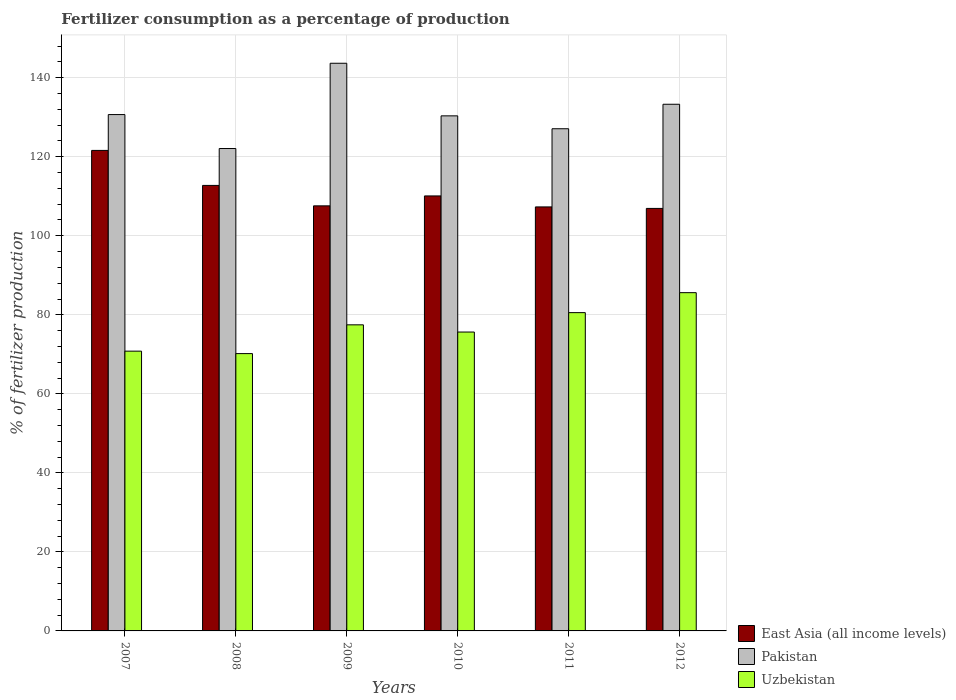How many groups of bars are there?
Keep it short and to the point. 6. How many bars are there on the 2nd tick from the right?
Offer a terse response. 3. What is the label of the 1st group of bars from the left?
Ensure brevity in your answer.  2007. In how many cases, is the number of bars for a given year not equal to the number of legend labels?
Ensure brevity in your answer.  0. What is the percentage of fertilizers consumed in Pakistan in 2011?
Give a very brief answer. 127.09. Across all years, what is the maximum percentage of fertilizers consumed in East Asia (all income levels)?
Your answer should be very brief. 121.6. Across all years, what is the minimum percentage of fertilizers consumed in East Asia (all income levels)?
Ensure brevity in your answer.  106.93. In which year was the percentage of fertilizers consumed in East Asia (all income levels) maximum?
Keep it short and to the point. 2007. In which year was the percentage of fertilizers consumed in Uzbekistan minimum?
Your response must be concise. 2008. What is the total percentage of fertilizers consumed in East Asia (all income levels) in the graph?
Give a very brief answer. 666.24. What is the difference between the percentage of fertilizers consumed in Uzbekistan in 2008 and that in 2011?
Your answer should be compact. -10.37. What is the difference between the percentage of fertilizers consumed in Uzbekistan in 2011 and the percentage of fertilizers consumed in East Asia (all income levels) in 2010?
Ensure brevity in your answer.  -29.53. What is the average percentage of fertilizers consumed in Uzbekistan per year?
Keep it short and to the point. 76.71. In the year 2007, what is the difference between the percentage of fertilizers consumed in Pakistan and percentage of fertilizers consumed in Uzbekistan?
Your answer should be very brief. 59.87. In how many years, is the percentage of fertilizers consumed in Pakistan greater than 44 %?
Offer a terse response. 6. What is the ratio of the percentage of fertilizers consumed in East Asia (all income levels) in 2008 to that in 2012?
Your answer should be very brief. 1.05. What is the difference between the highest and the second highest percentage of fertilizers consumed in East Asia (all income levels)?
Offer a very short reply. 8.86. What is the difference between the highest and the lowest percentage of fertilizers consumed in Pakistan?
Offer a terse response. 21.58. In how many years, is the percentage of fertilizers consumed in Pakistan greater than the average percentage of fertilizers consumed in Pakistan taken over all years?
Make the answer very short. 2. What does the 1st bar from the left in 2012 represents?
Keep it short and to the point. East Asia (all income levels). What does the 1st bar from the right in 2009 represents?
Provide a short and direct response. Uzbekistan. How many bars are there?
Provide a short and direct response. 18. Are all the bars in the graph horizontal?
Ensure brevity in your answer.  No. Are the values on the major ticks of Y-axis written in scientific E-notation?
Your response must be concise. No. Does the graph contain any zero values?
Your answer should be very brief. No. Where does the legend appear in the graph?
Give a very brief answer. Bottom right. How many legend labels are there?
Provide a short and direct response. 3. How are the legend labels stacked?
Give a very brief answer. Vertical. What is the title of the graph?
Offer a terse response. Fertilizer consumption as a percentage of production. What is the label or title of the Y-axis?
Your response must be concise. % of fertilizer production. What is the % of fertilizer production in East Asia (all income levels) in 2007?
Keep it short and to the point. 121.6. What is the % of fertilizer production in Pakistan in 2007?
Offer a very short reply. 130.68. What is the % of fertilizer production of Uzbekistan in 2007?
Your answer should be compact. 70.8. What is the % of fertilizer production in East Asia (all income levels) in 2008?
Keep it short and to the point. 112.75. What is the % of fertilizer production in Pakistan in 2008?
Give a very brief answer. 122.08. What is the % of fertilizer production of Uzbekistan in 2008?
Ensure brevity in your answer.  70.18. What is the % of fertilizer production in East Asia (all income levels) in 2009?
Offer a very short reply. 107.58. What is the % of fertilizer production in Pakistan in 2009?
Keep it short and to the point. 143.66. What is the % of fertilizer production in Uzbekistan in 2009?
Make the answer very short. 77.46. What is the % of fertilizer production in East Asia (all income levels) in 2010?
Your answer should be very brief. 110.09. What is the % of fertilizer production in Pakistan in 2010?
Offer a terse response. 130.35. What is the % of fertilizer production of Uzbekistan in 2010?
Offer a very short reply. 75.64. What is the % of fertilizer production of East Asia (all income levels) in 2011?
Offer a very short reply. 107.3. What is the % of fertilizer production in Pakistan in 2011?
Make the answer very short. 127.09. What is the % of fertilizer production of Uzbekistan in 2011?
Give a very brief answer. 80.55. What is the % of fertilizer production of East Asia (all income levels) in 2012?
Your answer should be very brief. 106.93. What is the % of fertilizer production in Pakistan in 2012?
Your answer should be very brief. 133.28. What is the % of fertilizer production in Uzbekistan in 2012?
Ensure brevity in your answer.  85.6. Across all years, what is the maximum % of fertilizer production of East Asia (all income levels)?
Your response must be concise. 121.6. Across all years, what is the maximum % of fertilizer production in Pakistan?
Keep it short and to the point. 143.66. Across all years, what is the maximum % of fertilizer production of Uzbekistan?
Your answer should be compact. 85.6. Across all years, what is the minimum % of fertilizer production of East Asia (all income levels)?
Keep it short and to the point. 106.93. Across all years, what is the minimum % of fertilizer production of Pakistan?
Your response must be concise. 122.08. Across all years, what is the minimum % of fertilizer production in Uzbekistan?
Your answer should be very brief. 70.18. What is the total % of fertilizer production in East Asia (all income levels) in the graph?
Your response must be concise. 666.24. What is the total % of fertilizer production in Pakistan in the graph?
Your response must be concise. 787.14. What is the total % of fertilizer production in Uzbekistan in the graph?
Ensure brevity in your answer.  460.25. What is the difference between the % of fertilizer production in East Asia (all income levels) in 2007 and that in 2008?
Make the answer very short. 8.86. What is the difference between the % of fertilizer production of Pakistan in 2007 and that in 2008?
Your response must be concise. 8.59. What is the difference between the % of fertilizer production of Uzbekistan in 2007 and that in 2008?
Your answer should be very brief. 0.62. What is the difference between the % of fertilizer production in East Asia (all income levels) in 2007 and that in 2009?
Your answer should be compact. 14.03. What is the difference between the % of fertilizer production in Pakistan in 2007 and that in 2009?
Your answer should be compact. -12.99. What is the difference between the % of fertilizer production of Uzbekistan in 2007 and that in 2009?
Ensure brevity in your answer.  -6.66. What is the difference between the % of fertilizer production in East Asia (all income levels) in 2007 and that in 2010?
Keep it short and to the point. 11.52. What is the difference between the % of fertilizer production of Pakistan in 2007 and that in 2010?
Offer a terse response. 0.32. What is the difference between the % of fertilizer production in Uzbekistan in 2007 and that in 2010?
Keep it short and to the point. -4.84. What is the difference between the % of fertilizer production of East Asia (all income levels) in 2007 and that in 2011?
Keep it short and to the point. 14.3. What is the difference between the % of fertilizer production of Pakistan in 2007 and that in 2011?
Your response must be concise. 3.59. What is the difference between the % of fertilizer production of Uzbekistan in 2007 and that in 2011?
Your response must be concise. -9.75. What is the difference between the % of fertilizer production in East Asia (all income levels) in 2007 and that in 2012?
Provide a short and direct response. 14.68. What is the difference between the % of fertilizer production of Pakistan in 2007 and that in 2012?
Your response must be concise. -2.61. What is the difference between the % of fertilizer production in Uzbekistan in 2007 and that in 2012?
Your answer should be very brief. -14.8. What is the difference between the % of fertilizer production of East Asia (all income levels) in 2008 and that in 2009?
Your answer should be compact. 5.17. What is the difference between the % of fertilizer production in Pakistan in 2008 and that in 2009?
Provide a short and direct response. -21.58. What is the difference between the % of fertilizer production of Uzbekistan in 2008 and that in 2009?
Your answer should be compact. -7.28. What is the difference between the % of fertilizer production in East Asia (all income levels) in 2008 and that in 2010?
Your answer should be compact. 2.66. What is the difference between the % of fertilizer production of Pakistan in 2008 and that in 2010?
Your answer should be very brief. -8.27. What is the difference between the % of fertilizer production in Uzbekistan in 2008 and that in 2010?
Your response must be concise. -5.46. What is the difference between the % of fertilizer production in East Asia (all income levels) in 2008 and that in 2011?
Keep it short and to the point. 5.44. What is the difference between the % of fertilizer production of Pakistan in 2008 and that in 2011?
Make the answer very short. -5.01. What is the difference between the % of fertilizer production in Uzbekistan in 2008 and that in 2011?
Provide a succinct answer. -10.37. What is the difference between the % of fertilizer production of East Asia (all income levels) in 2008 and that in 2012?
Ensure brevity in your answer.  5.82. What is the difference between the % of fertilizer production in Pakistan in 2008 and that in 2012?
Your response must be concise. -11.2. What is the difference between the % of fertilizer production in Uzbekistan in 2008 and that in 2012?
Ensure brevity in your answer.  -15.42. What is the difference between the % of fertilizer production of East Asia (all income levels) in 2009 and that in 2010?
Keep it short and to the point. -2.51. What is the difference between the % of fertilizer production in Pakistan in 2009 and that in 2010?
Your response must be concise. 13.31. What is the difference between the % of fertilizer production of Uzbekistan in 2009 and that in 2010?
Offer a terse response. 1.82. What is the difference between the % of fertilizer production of East Asia (all income levels) in 2009 and that in 2011?
Your answer should be compact. 0.27. What is the difference between the % of fertilizer production in Pakistan in 2009 and that in 2011?
Your answer should be very brief. 16.57. What is the difference between the % of fertilizer production of Uzbekistan in 2009 and that in 2011?
Ensure brevity in your answer.  -3.09. What is the difference between the % of fertilizer production of East Asia (all income levels) in 2009 and that in 2012?
Your response must be concise. 0.65. What is the difference between the % of fertilizer production of Pakistan in 2009 and that in 2012?
Provide a short and direct response. 10.38. What is the difference between the % of fertilizer production of Uzbekistan in 2009 and that in 2012?
Make the answer very short. -8.14. What is the difference between the % of fertilizer production in East Asia (all income levels) in 2010 and that in 2011?
Your response must be concise. 2.78. What is the difference between the % of fertilizer production in Pakistan in 2010 and that in 2011?
Your answer should be compact. 3.26. What is the difference between the % of fertilizer production of Uzbekistan in 2010 and that in 2011?
Your answer should be very brief. -4.91. What is the difference between the % of fertilizer production of East Asia (all income levels) in 2010 and that in 2012?
Provide a succinct answer. 3.16. What is the difference between the % of fertilizer production of Pakistan in 2010 and that in 2012?
Your response must be concise. -2.93. What is the difference between the % of fertilizer production of Uzbekistan in 2010 and that in 2012?
Your answer should be compact. -9.96. What is the difference between the % of fertilizer production of East Asia (all income levels) in 2011 and that in 2012?
Offer a terse response. 0.38. What is the difference between the % of fertilizer production in Pakistan in 2011 and that in 2012?
Make the answer very short. -6.19. What is the difference between the % of fertilizer production of Uzbekistan in 2011 and that in 2012?
Give a very brief answer. -5.05. What is the difference between the % of fertilizer production in East Asia (all income levels) in 2007 and the % of fertilizer production in Pakistan in 2008?
Provide a short and direct response. -0.48. What is the difference between the % of fertilizer production in East Asia (all income levels) in 2007 and the % of fertilizer production in Uzbekistan in 2008?
Provide a succinct answer. 51.42. What is the difference between the % of fertilizer production of Pakistan in 2007 and the % of fertilizer production of Uzbekistan in 2008?
Make the answer very short. 60.49. What is the difference between the % of fertilizer production in East Asia (all income levels) in 2007 and the % of fertilizer production in Pakistan in 2009?
Your answer should be very brief. -22.06. What is the difference between the % of fertilizer production in East Asia (all income levels) in 2007 and the % of fertilizer production in Uzbekistan in 2009?
Offer a very short reply. 44.14. What is the difference between the % of fertilizer production in Pakistan in 2007 and the % of fertilizer production in Uzbekistan in 2009?
Your response must be concise. 53.21. What is the difference between the % of fertilizer production in East Asia (all income levels) in 2007 and the % of fertilizer production in Pakistan in 2010?
Provide a succinct answer. -8.75. What is the difference between the % of fertilizer production of East Asia (all income levels) in 2007 and the % of fertilizer production of Uzbekistan in 2010?
Offer a terse response. 45.96. What is the difference between the % of fertilizer production in Pakistan in 2007 and the % of fertilizer production in Uzbekistan in 2010?
Your answer should be very brief. 55.03. What is the difference between the % of fertilizer production in East Asia (all income levels) in 2007 and the % of fertilizer production in Pakistan in 2011?
Your answer should be compact. -5.49. What is the difference between the % of fertilizer production of East Asia (all income levels) in 2007 and the % of fertilizer production of Uzbekistan in 2011?
Offer a very short reply. 41.05. What is the difference between the % of fertilizer production in Pakistan in 2007 and the % of fertilizer production in Uzbekistan in 2011?
Offer a very short reply. 50.12. What is the difference between the % of fertilizer production of East Asia (all income levels) in 2007 and the % of fertilizer production of Pakistan in 2012?
Provide a succinct answer. -11.68. What is the difference between the % of fertilizer production of East Asia (all income levels) in 2007 and the % of fertilizer production of Uzbekistan in 2012?
Your answer should be compact. 36. What is the difference between the % of fertilizer production in Pakistan in 2007 and the % of fertilizer production in Uzbekistan in 2012?
Provide a succinct answer. 45.07. What is the difference between the % of fertilizer production in East Asia (all income levels) in 2008 and the % of fertilizer production in Pakistan in 2009?
Your response must be concise. -30.91. What is the difference between the % of fertilizer production in East Asia (all income levels) in 2008 and the % of fertilizer production in Uzbekistan in 2009?
Give a very brief answer. 35.28. What is the difference between the % of fertilizer production in Pakistan in 2008 and the % of fertilizer production in Uzbekistan in 2009?
Provide a short and direct response. 44.62. What is the difference between the % of fertilizer production of East Asia (all income levels) in 2008 and the % of fertilizer production of Pakistan in 2010?
Ensure brevity in your answer.  -17.6. What is the difference between the % of fertilizer production in East Asia (all income levels) in 2008 and the % of fertilizer production in Uzbekistan in 2010?
Provide a succinct answer. 37.11. What is the difference between the % of fertilizer production of Pakistan in 2008 and the % of fertilizer production of Uzbekistan in 2010?
Ensure brevity in your answer.  46.44. What is the difference between the % of fertilizer production of East Asia (all income levels) in 2008 and the % of fertilizer production of Pakistan in 2011?
Keep it short and to the point. -14.34. What is the difference between the % of fertilizer production in East Asia (all income levels) in 2008 and the % of fertilizer production in Uzbekistan in 2011?
Your answer should be very brief. 32.19. What is the difference between the % of fertilizer production in Pakistan in 2008 and the % of fertilizer production in Uzbekistan in 2011?
Provide a short and direct response. 41.53. What is the difference between the % of fertilizer production in East Asia (all income levels) in 2008 and the % of fertilizer production in Pakistan in 2012?
Offer a terse response. -20.54. What is the difference between the % of fertilizer production in East Asia (all income levels) in 2008 and the % of fertilizer production in Uzbekistan in 2012?
Your answer should be compact. 27.14. What is the difference between the % of fertilizer production of Pakistan in 2008 and the % of fertilizer production of Uzbekistan in 2012?
Make the answer very short. 36.48. What is the difference between the % of fertilizer production in East Asia (all income levels) in 2009 and the % of fertilizer production in Pakistan in 2010?
Offer a terse response. -22.78. What is the difference between the % of fertilizer production of East Asia (all income levels) in 2009 and the % of fertilizer production of Uzbekistan in 2010?
Provide a short and direct response. 31.94. What is the difference between the % of fertilizer production of Pakistan in 2009 and the % of fertilizer production of Uzbekistan in 2010?
Provide a short and direct response. 68.02. What is the difference between the % of fertilizer production of East Asia (all income levels) in 2009 and the % of fertilizer production of Pakistan in 2011?
Provide a short and direct response. -19.51. What is the difference between the % of fertilizer production in East Asia (all income levels) in 2009 and the % of fertilizer production in Uzbekistan in 2011?
Offer a very short reply. 27.02. What is the difference between the % of fertilizer production of Pakistan in 2009 and the % of fertilizer production of Uzbekistan in 2011?
Make the answer very short. 63.11. What is the difference between the % of fertilizer production of East Asia (all income levels) in 2009 and the % of fertilizer production of Pakistan in 2012?
Provide a short and direct response. -25.71. What is the difference between the % of fertilizer production of East Asia (all income levels) in 2009 and the % of fertilizer production of Uzbekistan in 2012?
Your answer should be very brief. 21.97. What is the difference between the % of fertilizer production of Pakistan in 2009 and the % of fertilizer production of Uzbekistan in 2012?
Your response must be concise. 58.06. What is the difference between the % of fertilizer production of East Asia (all income levels) in 2010 and the % of fertilizer production of Pakistan in 2011?
Ensure brevity in your answer.  -17. What is the difference between the % of fertilizer production of East Asia (all income levels) in 2010 and the % of fertilizer production of Uzbekistan in 2011?
Ensure brevity in your answer.  29.53. What is the difference between the % of fertilizer production of Pakistan in 2010 and the % of fertilizer production of Uzbekistan in 2011?
Provide a short and direct response. 49.8. What is the difference between the % of fertilizer production of East Asia (all income levels) in 2010 and the % of fertilizer production of Pakistan in 2012?
Give a very brief answer. -23.2. What is the difference between the % of fertilizer production of East Asia (all income levels) in 2010 and the % of fertilizer production of Uzbekistan in 2012?
Your answer should be compact. 24.48. What is the difference between the % of fertilizer production in Pakistan in 2010 and the % of fertilizer production in Uzbekistan in 2012?
Provide a short and direct response. 44.75. What is the difference between the % of fertilizer production in East Asia (all income levels) in 2011 and the % of fertilizer production in Pakistan in 2012?
Offer a very short reply. -25.98. What is the difference between the % of fertilizer production of East Asia (all income levels) in 2011 and the % of fertilizer production of Uzbekistan in 2012?
Make the answer very short. 21.7. What is the difference between the % of fertilizer production in Pakistan in 2011 and the % of fertilizer production in Uzbekistan in 2012?
Your answer should be compact. 41.49. What is the average % of fertilizer production of East Asia (all income levels) per year?
Offer a very short reply. 111.04. What is the average % of fertilizer production of Pakistan per year?
Offer a very short reply. 131.19. What is the average % of fertilizer production in Uzbekistan per year?
Make the answer very short. 76.71. In the year 2007, what is the difference between the % of fertilizer production of East Asia (all income levels) and % of fertilizer production of Pakistan?
Offer a terse response. -9.07. In the year 2007, what is the difference between the % of fertilizer production in East Asia (all income levels) and % of fertilizer production in Uzbekistan?
Offer a terse response. 50.8. In the year 2007, what is the difference between the % of fertilizer production in Pakistan and % of fertilizer production in Uzbekistan?
Keep it short and to the point. 59.87. In the year 2008, what is the difference between the % of fertilizer production of East Asia (all income levels) and % of fertilizer production of Pakistan?
Provide a short and direct response. -9.33. In the year 2008, what is the difference between the % of fertilizer production in East Asia (all income levels) and % of fertilizer production in Uzbekistan?
Provide a short and direct response. 42.56. In the year 2008, what is the difference between the % of fertilizer production of Pakistan and % of fertilizer production of Uzbekistan?
Offer a very short reply. 51.9. In the year 2009, what is the difference between the % of fertilizer production of East Asia (all income levels) and % of fertilizer production of Pakistan?
Make the answer very short. -36.08. In the year 2009, what is the difference between the % of fertilizer production of East Asia (all income levels) and % of fertilizer production of Uzbekistan?
Give a very brief answer. 30.11. In the year 2009, what is the difference between the % of fertilizer production in Pakistan and % of fertilizer production in Uzbekistan?
Keep it short and to the point. 66.2. In the year 2010, what is the difference between the % of fertilizer production of East Asia (all income levels) and % of fertilizer production of Pakistan?
Keep it short and to the point. -20.27. In the year 2010, what is the difference between the % of fertilizer production in East Asia (all income levels) and % of fertilizer production in Uzbekistan?
Offer a very short reply. 34.45. In the year 2010, what is the difference between the % of fertilizer production of Pakistan and % of fertilizer production of Uzbekistan?
Provide a short and direct response. 54.71. In the year 2011, what is the difference between the % of fertilizer production in East Asia (all income levels) and % of fertilizer production in Pakistan?
Offer a terse response. -19.79. In the year 2011, what is the difference between the % of fertilizer production in East Asia (all income levels) and % of fertilizer production in Uzbekistan?
Your answer should be very brief. 26.75. In the year 2011, what is the difference between the % of fertilizer production in Pakistan and % of fertilizer production in Uzbekistan?
Keep it short and to the point. 46.54. In the year 2012, what is the difference between the % of fertilizer production in East Asia (all income levels) and % of fertilizer production in Pakistan?
Provide a short and direct response. -26.36. In the year 2012, what is the difference between the % of fertilizer production of East Asia (all income levels) and % of fertilizer production of Uzbekistan?
Offer a very short reply. 21.32. In the year 2012, what is the difference between the % of fertilizer production of Pakistan and % of fertilizer production of Uzbekistan?
Your answer should be very brief. 47.68. What is the ratio of the % of fertilizer production of East Asia (all income levels) in 2007 to that in 2008?
Your answer should be compact. 1.08. What is the ratio of the % of fertilizer production in Pakistan in 2007 to that in 2008?
Offer a terse response. 1.07. What is the ratio of the % of fertilizer production in Uzbekistan in 2007 to that in 2008?
Your answer should be compact. 1.01. What is the ratio of the % of fertilizer production in East Asia (all income levels) in 2007 to that in 2009?
Your response must be concise. 1.13. What is the ratio of the % of fertilizer production of Pakistan in 2007 to that in 2009?
Make the answer very short. 0.91. What is the ratio of the % of fertilizer production in Uzbekistan in 2007 to that in 2009?
Offer a terse response. 0.91. What is the ratio of the % of fertilizer production in East Asia (all income levels) in 2007 to that in 2010?
Give a very brief answer. 1.1. What is the ratio of the % of fertilizer production of Pakistan in 2007 to that in 2010?
Give a very brief answer. 1. What is the ratio of the % of fertilizer production in Uzbekistan in 2007 to that in 2010?
Ensure brevity in your answer.  0.94. What is the ratio of the % of fertilizer production in East Asia (all income levels) in 2007 to that in 2011?
Offer a terse response. 1.13. What is the ratio of the % of fertilizer production of Pakistan in 2007 to that in 2011?
Offer a terse response. 1.03. What is the ratio of the % of fertilizer production of Uzbekistan in 2007 to that in 2011?
Keep it short and to the point. 0.88. What is the ratio of the % of fertilizer production of East Asia (all income levels) in 2007 to that in 2012?
Keep it short and to the point. 1.14. What is the ratio of the % of fertilizer production of Pakistan in 2007 to that in 2012?
Offer a terse response. 0.98. What is the ratio of the % of fertilizer production of Uzbekistan in 2007 to that in 2012?
Your answer should be compact. 0.83. What is the ratio of the % of fertilizer production in East Asia (all income levels) in 2008 to that in 2009?
Provide a short and direct response. 1.05. What is the ratio of the % of fertilizer production in Pakistan in 2008 to that in 2009?
Give a very brief answer. 0.85. What is the ratio of the % of fertilizer production of Uzbekistan in 2008 to that in 2009?
Your answer should be very brief. 0.91. What is the ratio of the % of fertilizer production of East Asia (all income levels) in 2008 to that in 2010?
Offer a terse response. 1.02. What is the ratio of the % of fertilizer production in Pakistan in 2008 to that in 2010?
Your answer should be very brief. 0.94. What is the ratio of the % of fertilizer production in Uzbekistan in 2008 to that in 2010?
Give a very brief answer. 0.93. What is the ratio of the % of fertilizer production of East Asia (all income levels) in 2008 to that in 2011?
Provide a succinct answer. 1.05. What is the ratio of the % of fertilizer production of Pakistan in 2008 to that in 2011?
Provide a short and direct response. 0.96. What is the ratio of the % of fertilizer production in Uzbekistan in 2008 to that in 2011?
Make the answer very short. 0.87. What is the ratio of the % of fertilizer production of East Asia (all income levels) in 2008 to that in 2012?
Keep it short and to the point. 1.05. What is the ratio of the % of fertilizer production of Pakistan in 2008 to that in 2012?
Make the answer very short. 0.92. What is the ratio of the % of fertilizer production in Uzbekistan in 2008 to that in 2012?
Your answer should be very brief. 0.82. What is the ratio of the % of fertilizer production of East Asia (all income levels) in 2009 to that in 2010?
Make the answer very short. 0.98. What is the ratio of the % of fertilizer production in Pakistan in 2009 to that in 2010?
Offer a terse response. 1.1. What is the ratio of the % of fertilizer production of Uzbekistan in 2009 to that in 2010?
Provide a succinct answer. 1.02. What is the ratio of the % of fertilizer production of East Asia (all income levels) in 2009 to that in 2011?
Your answer should be compact. 1. What is the ratio of the % of fertilizer production in Pakistan in 2009 to that in 2011?
Make the answer very short. 1.13. What is the ratio of the % of fertilizer production of Uzbekistan in 2009 to that in 2011?
Ensure brevity in your answer.  0.96. What is the ratio of the % of fertilizer production in Pakistan in 2009 to that in 2012?
Your response must be concise. 1.08. What is the ratio of the % of fertilizer production in Uzbekistan in 2009 to that in 2012?
Make the answer very short. 0.9. What is the ratio of the % of fertilizer production in East Asia (all income levels) in 2010 to that in 2011?
Offer a very short reply. 1.03. What is the ratio of the % of fertilizer production of Pakistan in 2010 to that in 2011?
Ensure brevity in your answer.  1.03. What is the ratio of the % of fertilizer production of Uzbekistan in 2010 to that in 2011?
Ensure brevity in your answer.  0.94. What is the ratio of the % of fertilizer production in East Asia (all income levels) in 2010 to that in 2012?
Your response must be concise. 1.03. What is the ratio of the % of fertilizer production of Uzbekistan in 2010 to that in 2012?
Your answer should be compact. 0.88. What is the ratio of the % of fertilizer production of East Asia (all income levels) in 2011 to that in 2012?
Keep it short and to the point. 1. What is the ratio of the % of fertilizer production in Pakistan in 2011 to that in 2012?
Make the answer very short. 0.95. What is the ratio of the % of fertilizer production in Uzbekistan in 2011 to that in 2012?
Your response must be concise. 0.94. What is the difference between the highest and the second highest % of fertilizer production of East Asia (all income levels)?
Give a very brief answer. 8.86. What is the difference between the highest and the second highest % of fertilizer production of Pakistan?
Offer a terse response. 10.38. What is the difference between the highest and the second highest % of fertilizer production of Uzbekistan?
Your answer should be very brief. 5.05. What is the difference between the highest and the lowest % of fertilizer production in East Asia (all income levels)?
Provide a succinct answer. 14.68. What is the difference between the highest and the lowest % of fertilizer production in Pakistan?
Your answer should be very brief. 21.58. What is the difference between the highest and the lowest % of fertilizer production in Uzbekistan?
Make the answer very short. 15.42. 